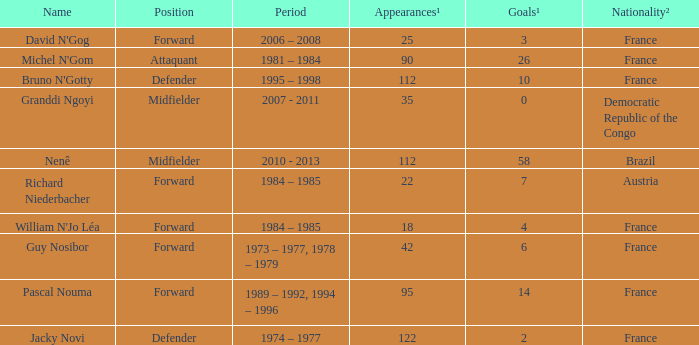What is the duration of attaquant's active years? 1981 – 1984. Could you help me parse every detail presented in this table? {'header': ['Name', 'Position', 'Period', 'Appearances¹', 'Goals¹', 'Nationality²'], 'rows': [["David N'Gog", 'Forward', '2006 – 2008', '25', '3', 'France'], ["Michel N'Gom", 'Attaquant', '1981 – 1984', '90', '26', 'France'], ["Bruno N'Gotty", 'Defender', '1995 – 1998', '112', '10', 'France'], ['Granddi Ngoyi', 'Midfielder', '2007 - 2011', '35', '0', 'Democratic Republic of the Congo'], ['Nenê', 'Midfielder', '2010 - 2013', '112', '58', 'Brazil'], ['Richard Niederbacher', 'Forward', '1984 – 1985', '22', '7', 'Austria'], ["William N'Jo Léa", 'Forward', '1984 – 1985', '18', '4', 'France'], ['Guy Nosibor', 'Forward', '1973 – 1977, 1978 – 1979', '42', '6', 'France'], ['Pascal Nouma', 'Forward', '1989 – 1992, 1994 – 1996', '95', '14', 'France'], ['Jacky Novi', 'Defender', '1974 – 1977', '122', '2', 'France']]} 